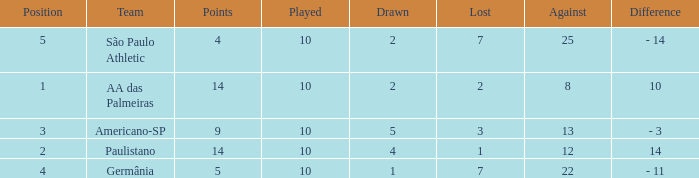What team has an against more than 8, lost of 7, and the position is 5? São Paulo Athletic. 